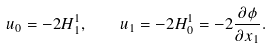<formula> <loc_0><loc_0><loc_500><loc_500>u _ { 0 } = - 2 H _ { 1 } ^ { 1 } , \quad u _ { 1 } = - 2 H _ { 0 } ^ { 1 } = - 2 \frac { \partial { \phi } } { \partial { x _ { 1 } } } .</formula> 